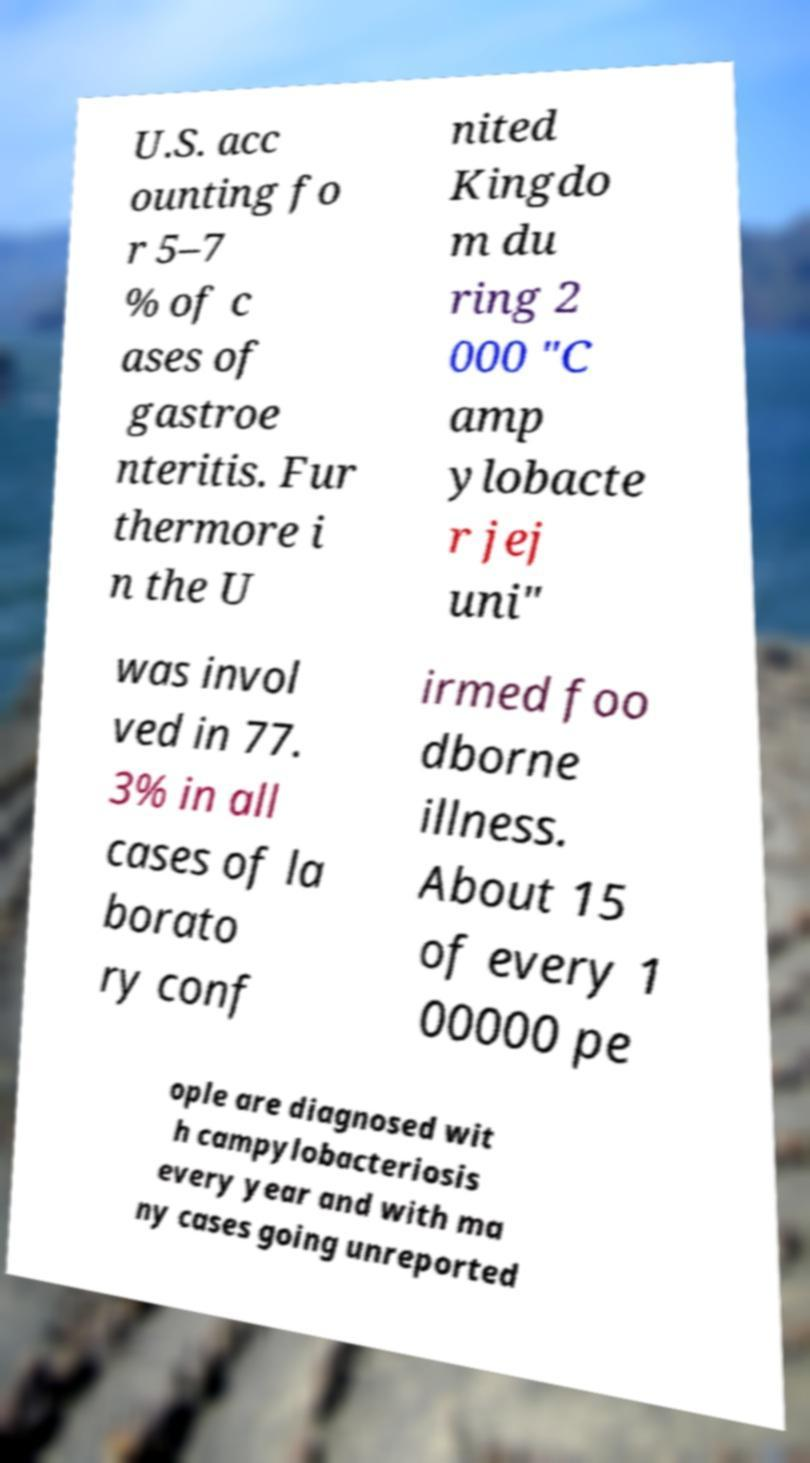I need the written content from this picture converted into text. Can you do that? U.S. acc ounting fo r 5–7 % of c ases of gastroe nteritis. Fur thermore i n the U nited Kingdo m du ring 2 000 "C amp ylobacte r jej uni" was invol ved in 77. 3% in all cases of la borato ry conf irmed foo dborne illness. About 15 of every 1 00000 pe ople are diagnosed wit h campylobacteriosis every year and with ma ny cases going unreported 